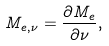<formula> <loc_0><loc_0><loc_500><loc_500>M _ { e , \nu } = { \frac { \partial M _ { e } } { \partial \nu } } ,</formula> 